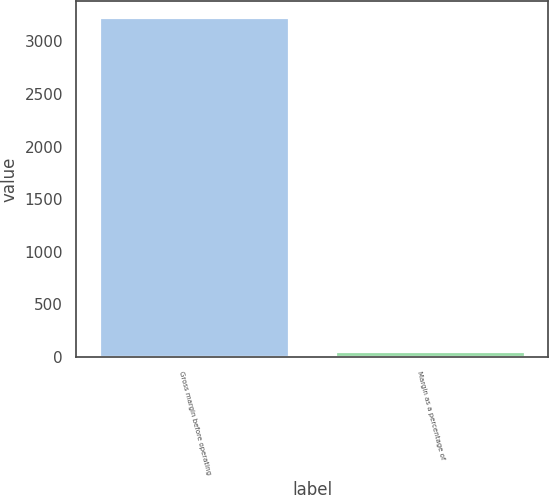Convert chart. <chart><loc_0><loc_0><loc_500><loc_500><bar_chart><fcel>Gross margin before operating<fcel>Margin as a percentage of<nl><fcel>3220<fcel>47<nl></chart> 